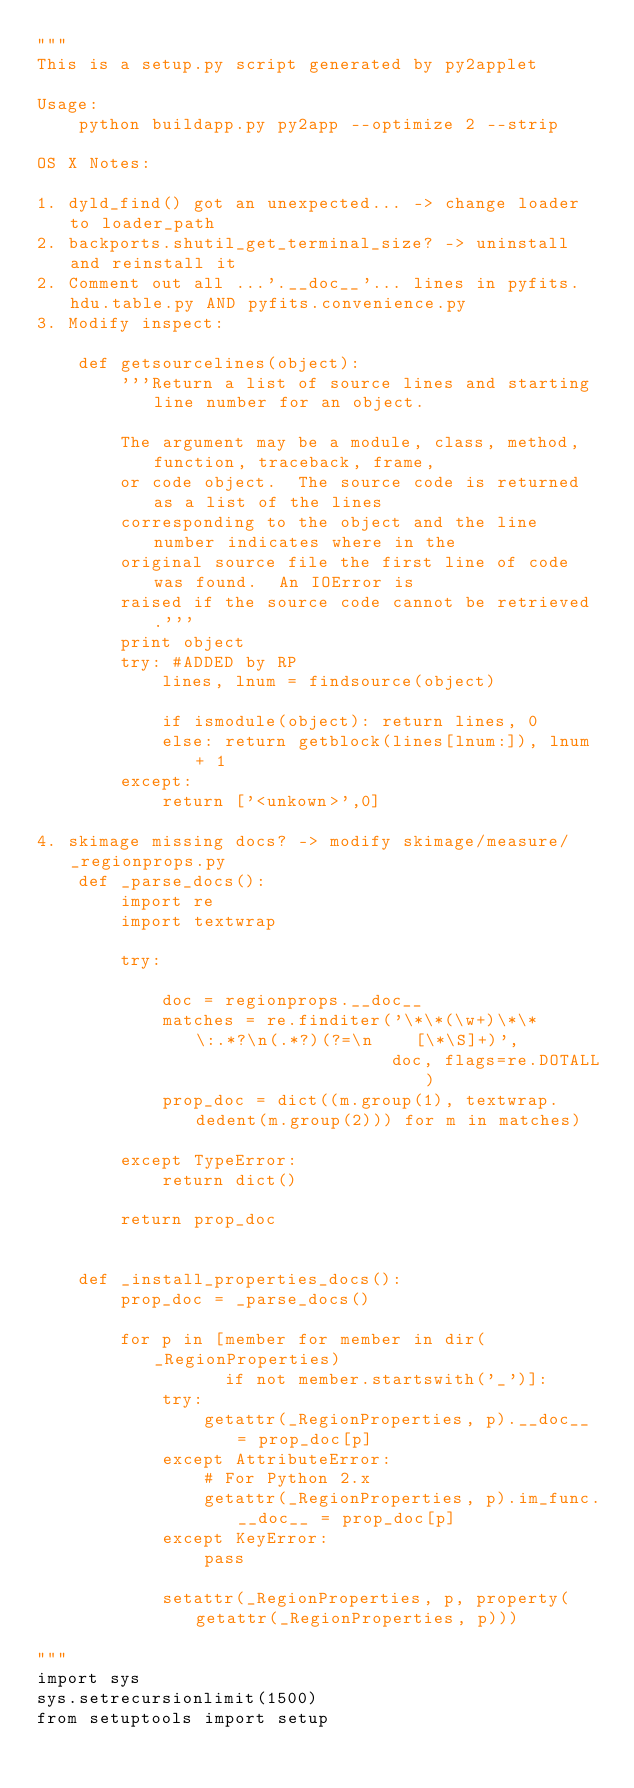Convert code to text. <code><loc_0><loc_0><loc_500><loc_500><_Python_>"""
This is a setup.py script generated by py2applet

Usage:
    python buildapp.py py2app --optimize 2 --strip

OS X Notes:

1. dyld_find() got an unexpected... -> change loader to loader_path
2. backports.shutil_get_terminal_size? -> uninstall and reinstall it
2. Comment out all ...'.__doc__'... lines in pyfits.hdu.table.py AND pyfits.convenience.py
3. Modify inspect:

    def getsourcelines(object):
        '''Return a list of source lines and starting line number for an object.

        The argument may be a module, class, method, function, traceback, frame,
        or code object.  The source code is returned as a list of the lines
        corresponding to the object and the line number indicates where in the
        original source file the first line of code was found.  An IOError is
        raised if the source code cannot be retrieved.'''
        print object
        try: #ADDED by RP
            lines, lnum = findsource(object)

            if ismodule(object): return lines, 0
            else: return getblock(lines[lnum:]), lnum + 1
        except:
            return ['<unkown>',0]

4. skimage missing docs? -> modify skimage/measure/_regionprops.py
    def _parse_docs():
        import re
        import textwrap

        try:

            doc = regionprops.__doc__
            matches = re.finditer('\*\*(\w+)\*\* \:.*?\n(.*?)(?=\n    [\*\S]+)',
                                  doc, flags=re.DOTALL)
            prop_doc = dict((m.group(1), textwrap.dedent(m.group(2))) for m in matches)

        except TypeError:
            return dict()

        return prop_doc


    def _install_properties_docs():
        prop_doc = _parse_docs()

        for p in [member for member in dir(_RegionProperties)
                  if not member.startswith('_')]:
            try:
                getattr(_RegionProperties, p).__doc__ = prop_doc[p]
            except AttributeError:
                # For Python 2.x
                getattr(_RegionProperties, p).im_func.__doc__ = prop_doc[p]
            except KeyError:
                pass

            setattr(_RegionProperties, p, property(getattr(_RegionProperties, p)))

"""
import sys
sys.setrecursionlimit(1500)
from setuptools import setup</code> 